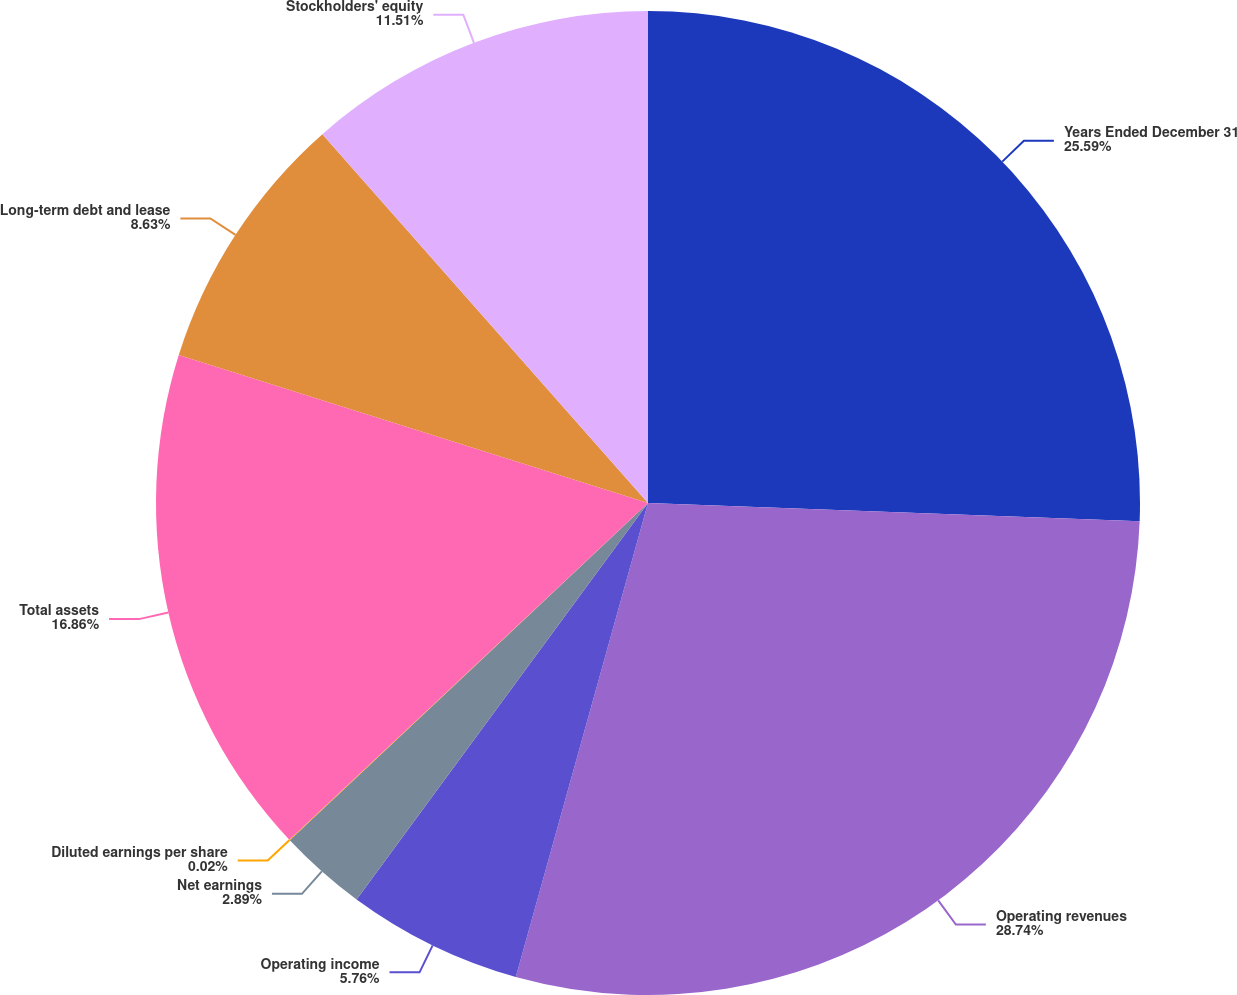Convert chart to OTSL. <chart><loc_0><loc_0><loc_500><loc_500><pie_chart><fcel>Years Ended December 31<fcel>Operating revenues<fcel>Operating income<fcel>Net earnings<fcel>Diluted earnings per share<fcel>Total assets<fcel>Long-term debt and lease<fcel>Stockholders' equity<nl><fcel>25.59%<fcel>28.74%<fcel>5.76%<fcel>2.89%<fcel>0.02%<fcel>16.86%<fcel>8.63%<fcel>11.51%<nl></chart> 